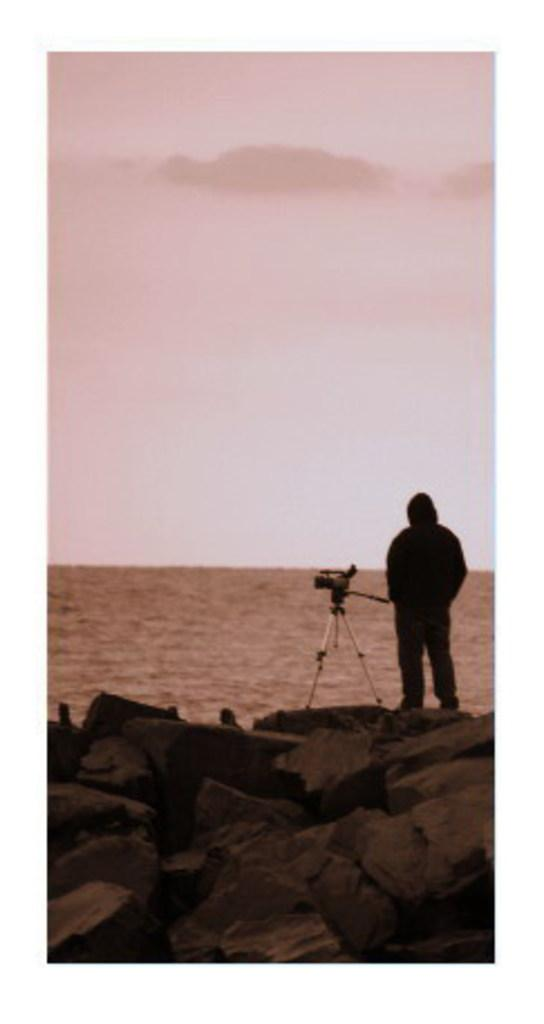What is the main subject of the image? There is a person in the image. What object can be seen near the person? There is a camera placed on a stand. What type of terrain is visible at the bottom of the image? There are rocks at the bottom of the image. What natural elements can be seen in the background of the image? Water and the sky are visible in the background of the image. What type of glue is being used to attach the zinc to the rocks in the image? There is no glue, zinc, or attachment process depicted in the image. 